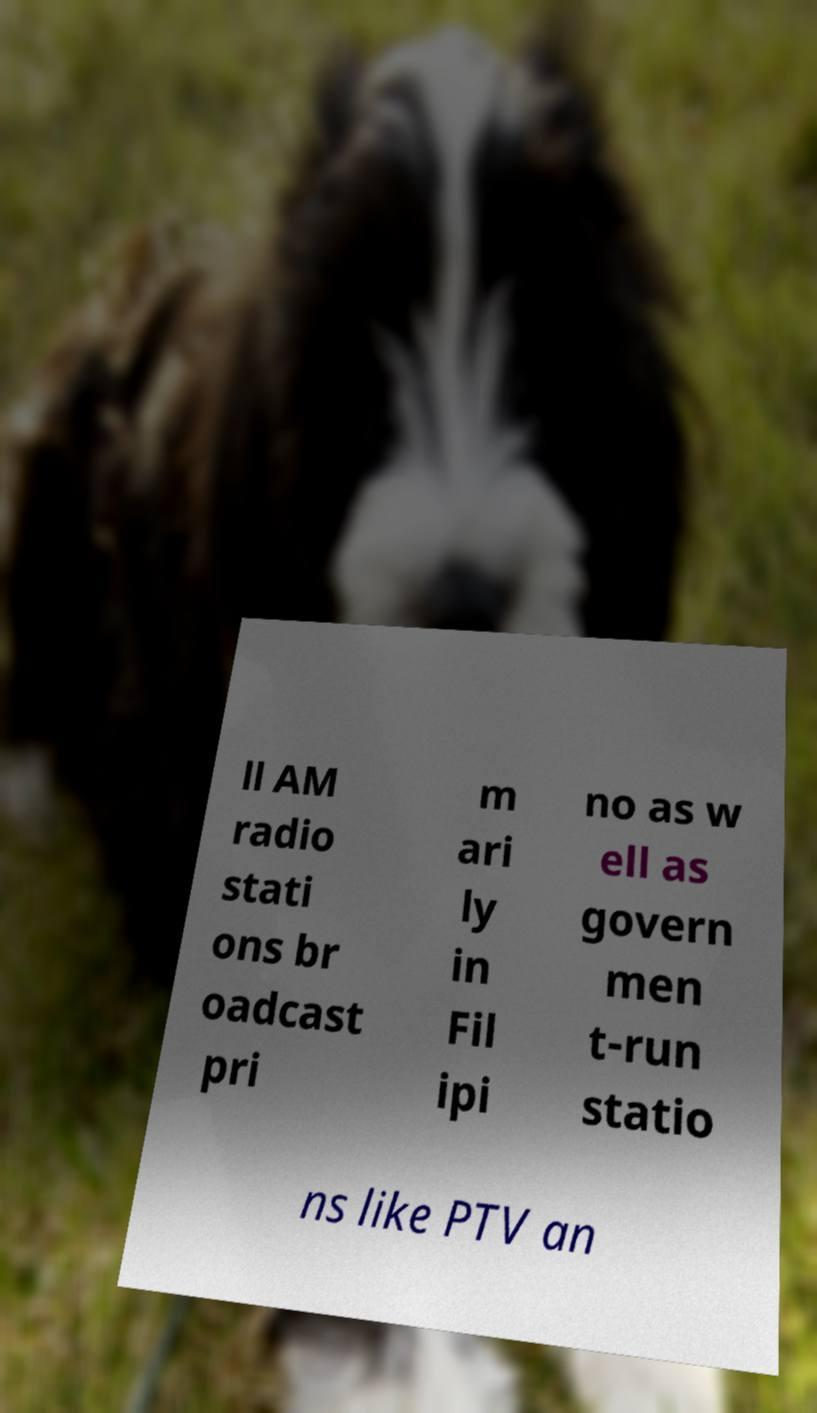Please identify and transcribe the text found in this image. ll AM radio stati ons br oadcast pri m ari ly in Fil ipi no as w ell as govern men t-run statio ns like PTV an 